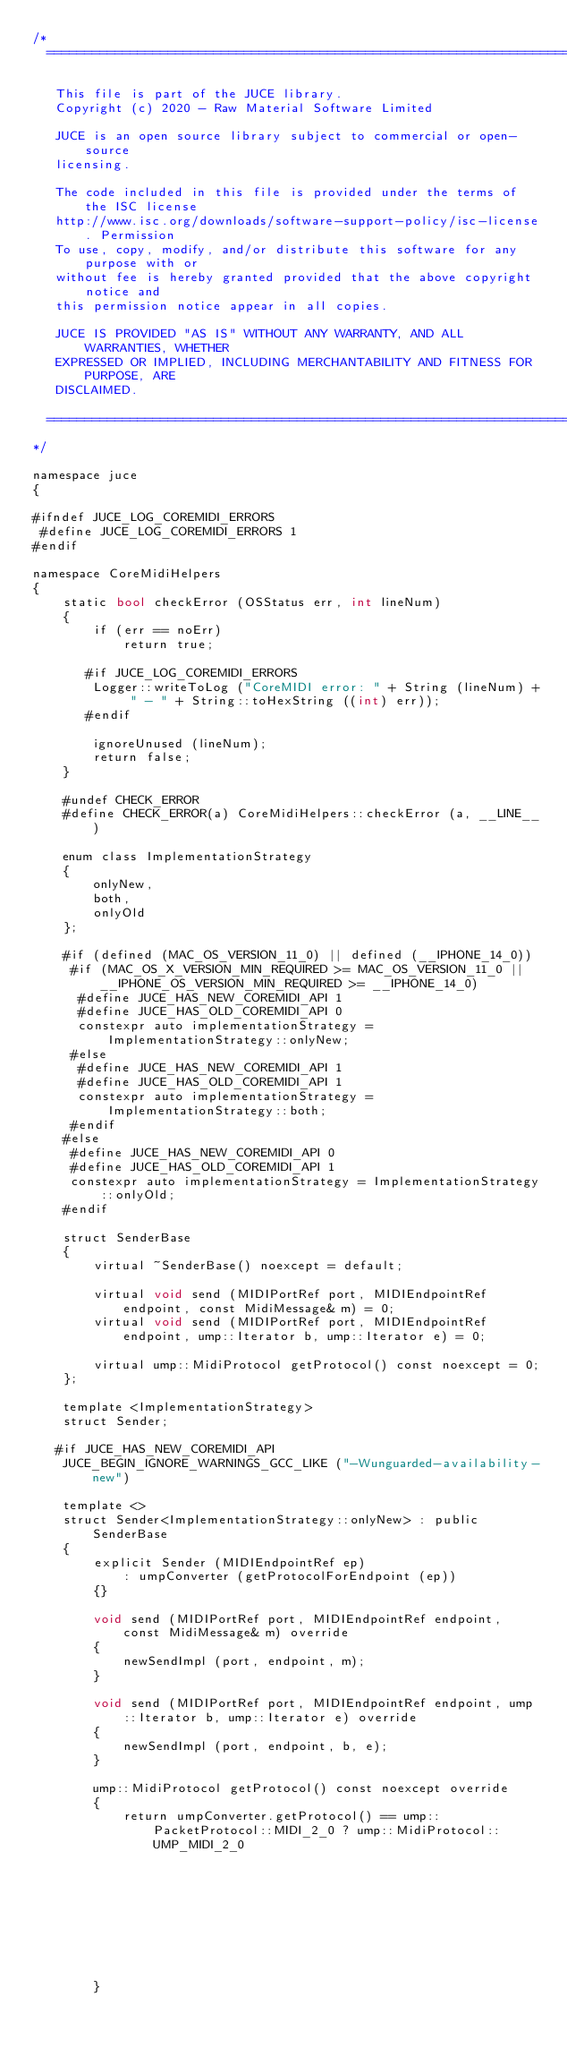Convert code to text. <code><loc_0><loc_0><loc_500><loc_500><_ObjectiveC_>/*
  ==============================================================================

   This file is part of the JUCE library.
   Copyright (c) 2020 - Raw Material Software Limited

   JUCE is an open source library subject to commercial or open-source
   licensing.

   The code included in this file is provided under the terms of the ISC license
   http://www.isc.org/downloads/software-support-policy/isc-license. Permission
   To use, copy, modify, and/or distribute this software for any purpose with or
   without fee is hereby granted provided that the above copyright notice and
   this permission notice appear in all copies.

   JUCE IS PROVIDED "AS IS" WITHOUT ANY WARRANTY, AND ALL WARRANTIES, WHETHER
   EXPRESSED OR IMPLIED, INCLUDING MERCHANTABILITY AND FITNESS FOR PURPOSE, ARE
   DISCLAIMED.

  ==============================================================================
*/

namespace juce
{

#ifndef JUCE_LOG_COREMIDI_ERRORS
 #define JUCE_LOG_COREMIDI_ERRORS 1
#endif

namespace CoreMidiHelpers
{
    static bool checkError (OSStatus err, int lineNum)
    {
        if (err == noErr)
            return true;

       #if JUCE_LOG_COREMIDI_ERRORS
        Logger::writeToLog ("CoreMIDI error: " + String (lineNum) + " - " + String::toHexString ((int) err));
       #endif

        ignoreUnused (lineNum);
        return false;
    }

    #undef CHECK_ERROR
    #define CHECK_ERROR(a) CoreMidiHelpers::checkError (a, __LINE__)

    enum class ImplementationStrategy
    {
        onlyNew,
        both,
        onlyOld
    };

    #if (defined (MAC_OS_VERSION_11_0) || defined (__IPHONE_14_0))
     #if (MAC_OS_X_VERSION_MIN_REQUIRED >= MAC_OS_VERSION_11_0 || __IPHONE_OS_VERSION_MIN_REQUIRED >= __IPHONE_14_0)
      #define JUCE_HAS_NEW_COREMIDI_API 1
      #define JUCE_HAS_OLD_COREMIDI_API 0
      constexpr auto implementationStrategy = ImplementationStrategy::onlyNew;
     #else
      #define JUCE_HAS_NEW_COREMIDI_API 1
      #define JUCE_HAS_OLD_COREMIDI_API 1
      constexpr auto implementationStrategy = ImplementationStrategy::both;
     #endif
    #else
     #define JUCE_HAS_NEW_COREMIDI_API 0
     #define JUCE_HAS_OLD_COREMIDI_API 1
     constexpr auto implementationStrategy = ImplementationStrategy::onlyOld;
    #endif

    struct SenderBase
    {
        virtual ~SenderBase() noexcept = default;

        virtual void send (MIDIPortRef port, MIDIEndpointRef endpoint, const MidiMessage& m) = 0;
        virtual void send (MIDIPortRef port, MIDIEndpointRef endpoint, ump::Iterator b, ump::Iterator e) = 0;

        virtual ump::MidiProtocol getProtocol() const noexcept = 0;
    };

    template <ImplementationStrategy>
    struct Sender;

   #if JUCE_HAS_NEW_COREMIDI_API
    JUCE_BEGIN_IGNORE_WARNINGS_GCC_LIKE ("-Wunguarded-availability-new")

    template <>
    struct Sender<ImplementationStrategy::onlyNew> : public SenderBase
    {
        explicit Sender (MIDIEndpointRef ep)
            : umpConverter (getProtocolForEndpoint (ep))
        {}

        void send (MIDIPortRef port, MIDIEndpointRef endpoint, const MidiMessage& m) override
        {
            newSendImpl (port, endpoint, m);
        }

        void send (MIDIPortRef port, MIDIEndpointRef endpoint, ump::Iterator b, ump::Iterator e) override
        {
            newSendImpl (port, endpoint, b, e);
        }

        ump::MidiProtocol getProtocol() const noexcept override
        {
            return umpConverter.getProtocol() == ump::PacketProtocol::MIDI_2_0 ? ump::MidiProtocol::UMP_MIDI_2_0
                                                                               : ump::MidiProtocol::UMP_MIDI_1_0;
        }
</code> 